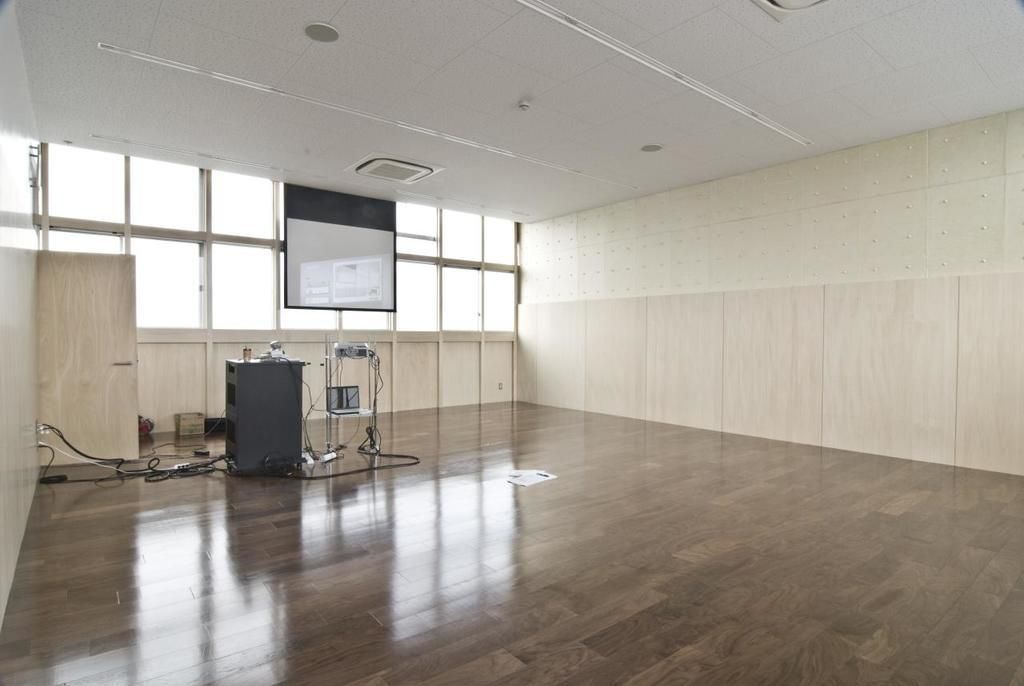What is the general appearance of the room in the image? The room in the image is empty. What can be seen on the left side of the room? There is a screen on the left side of the room. What device is present in the room for displaying images or videos? There is a projector in the room. What allows natural light to enter the room? There are windows in the room. How many toes can be seen on the boy in the image? A: There is no boy present in the image, so it is not possible to determine the number of toes visible. 